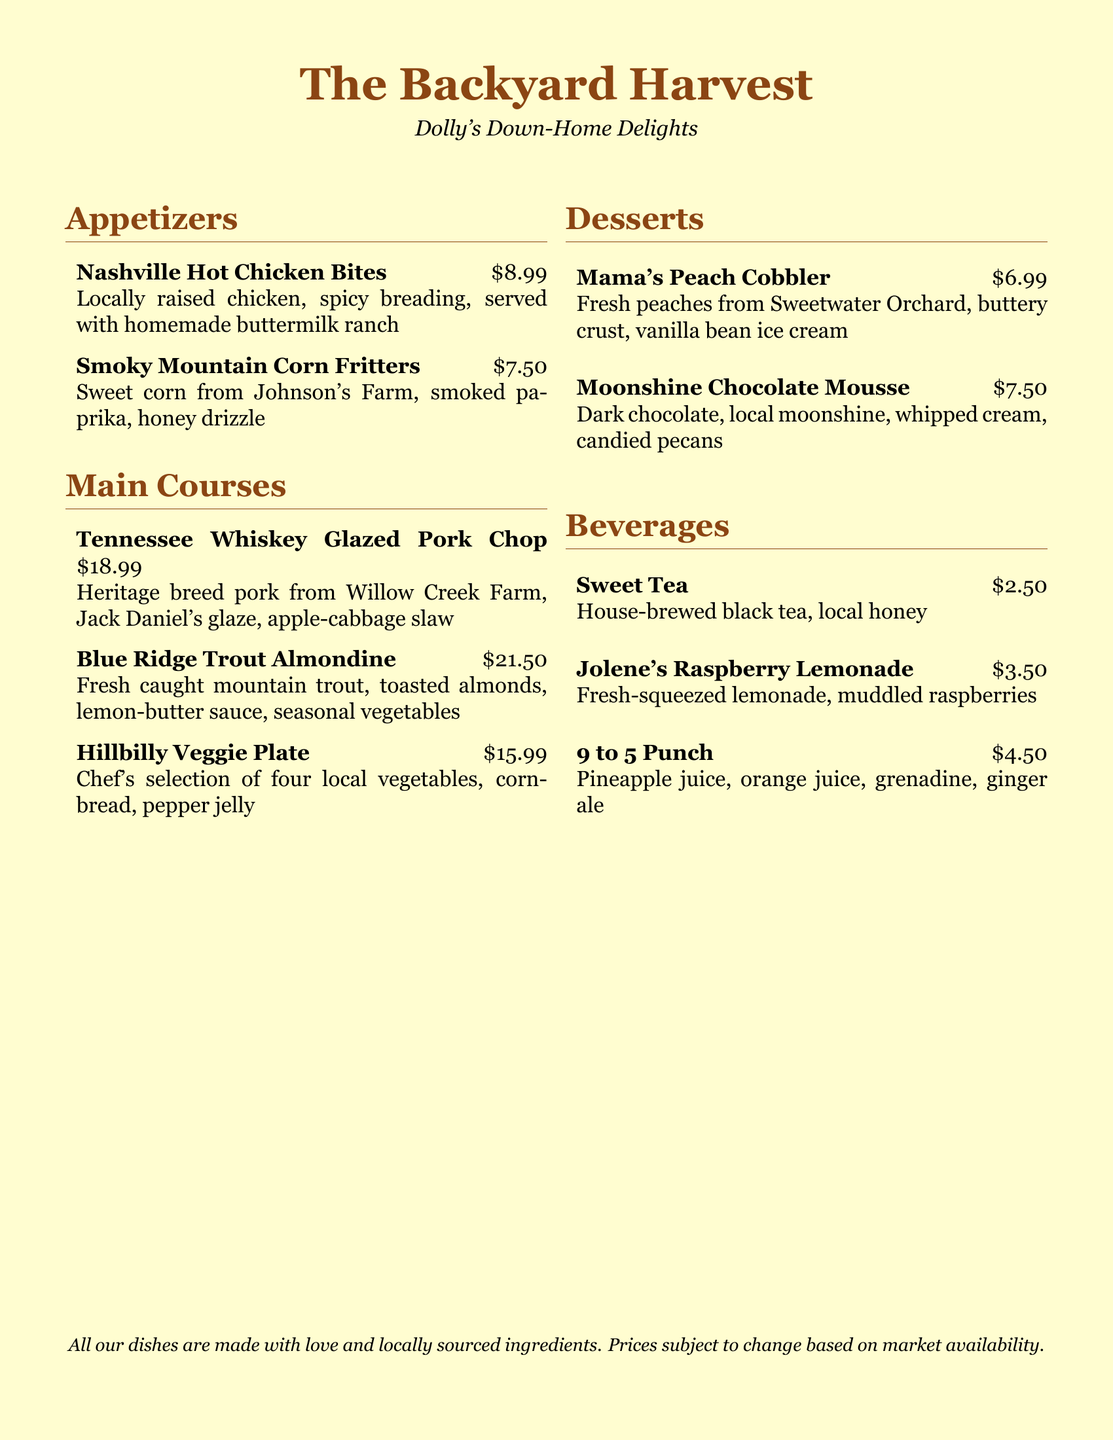What is the name of the restaurant? The name of the restaurant is stated at the top of the menu.
Answer: The Backyard Harvest What is the price of the Nashville Hot Chicken Bites? The price for the Nashville Hot Chicken Bites is listed next to the dish.
Answer: $8.99 Which farm supplies the heritage breed pork for the pork chop? The farm that supplies the pork is mentioned in the description of the dish.
Answer: Willow Creek Farm What is used to add flavor to the Smoky Mountain Corn Fritters? The ingredients used in the dish are provided in the description.
Answer: Smoked paprika How many local vegetables are in the Hillbilly Veggie Plate? The menu states the quantity of vegetables included in the dish.
Answer: Four What dessert includes fresh peaches? The dessert names are listed along with their main ingredients.
Answer: Mama's Peach Cobbler What is the main ingredient in Moonshine Chocolate Mousse? The ingredients for the dessert are included in the description.
Answer: Dark chocolate What beverage is made with local honey? The beverages are described, and one mentions using local honey.
Answer: Sweet Tea How much does the 9 to 5 Punch cost? The price of the 9 to 5 Punch is indicated in the beverage section.
Answer: $4.50 